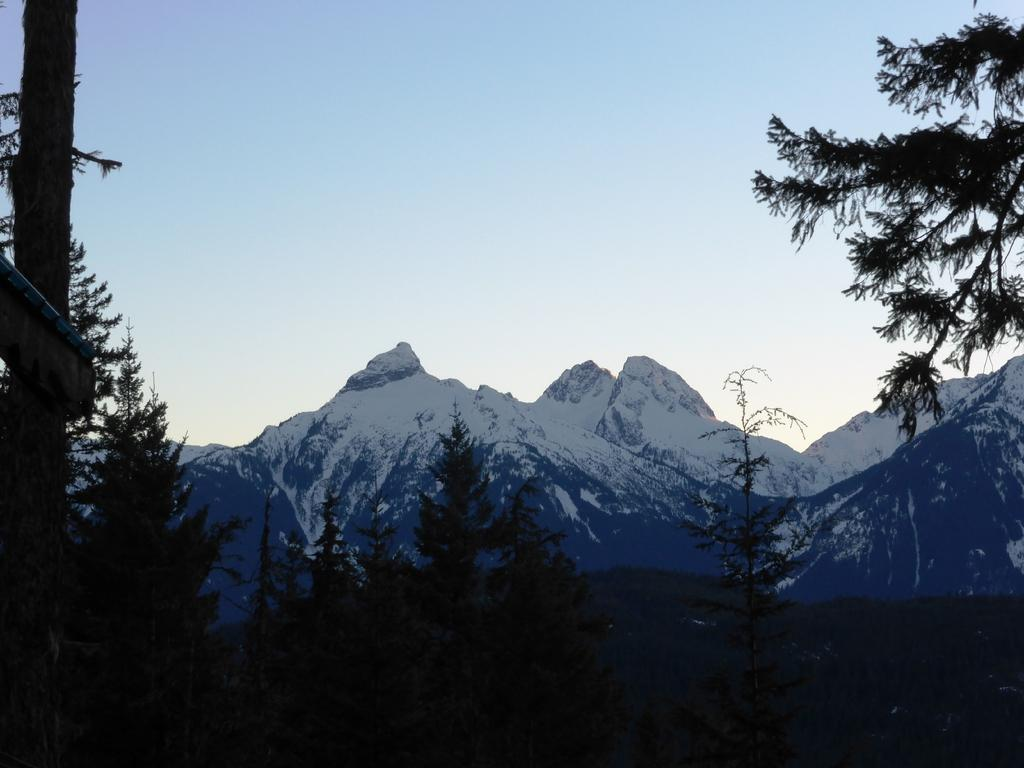What type of vegetation can be seen in the image? There are trees in the image. What can be seen on the mountains in the background of the image? There is snow on the mountains in the background of the image. What part of the natural environment is visible in the image? The sky is visible in the image. How many snakes are slithering through the trees in the image? There are no snakes present in the image; it features trees and snow-covered mountains. What is the monetary value of the trees in the image? The image does not provide any information about the monetary value of the trees. 